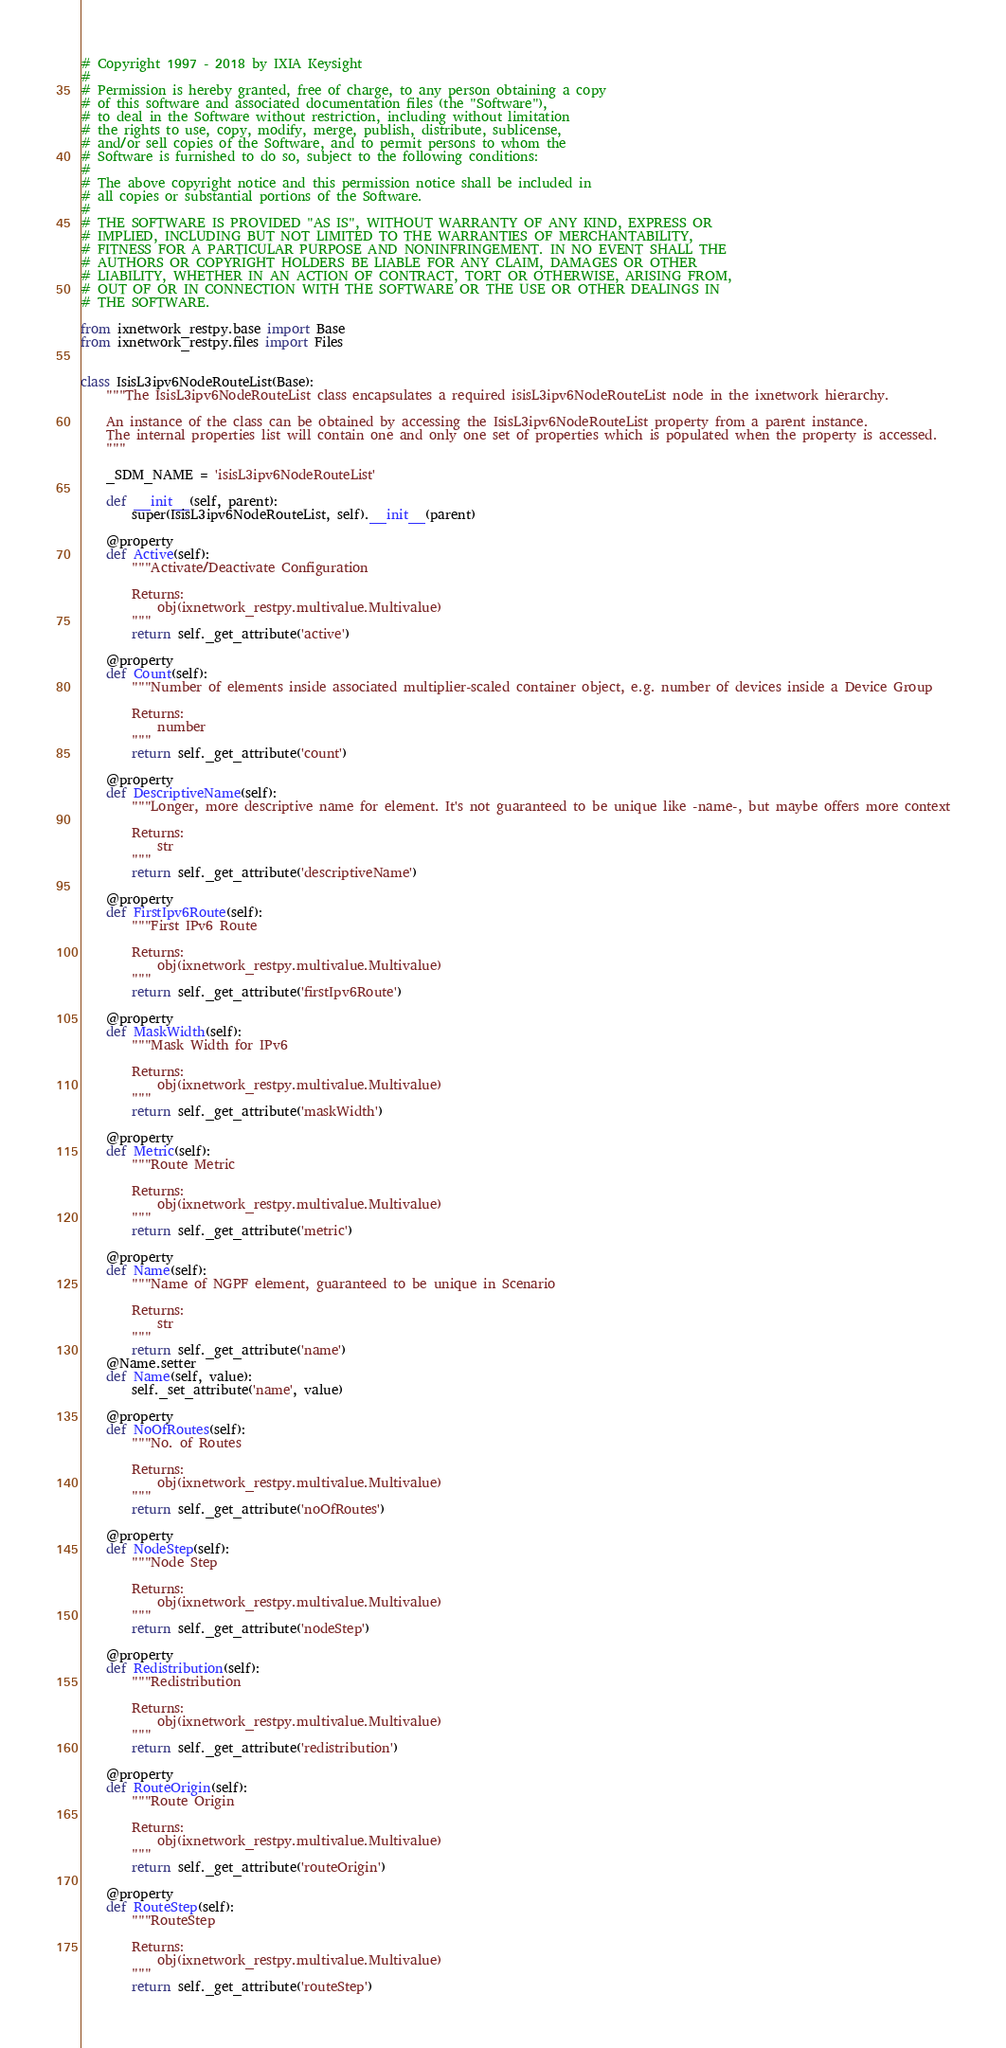Convert code to text. <code><loc_0><loc_0><loc_500><loc_500><_Python_>
# Copyright 1997 - 2018 by IXIA Keysight
#
# Permission is hereby granted, free of charge, to any person obtaining a copy
# of this software and associated documentation files (the "Software"),
# to deal in the Software without restriction, including without limitation
# the rights to use, copy, modify, merge, publish, distribute, sublicense,
# and/or sell copies of the Software, and to permit persons to whom the
# Software is furnished to do so, subject to the following conditions:
#
# The above copyright notice and this permission notice shall be included in
# all copies or substantial portions of the Software.
#
# THE SOFTWARE IS PROVIDED "AS IS", WITHOUT WARRANTY OF ANY KIND, EXPRESS OR
# IMPLIED, INCLUDING BUT NOT LIMITED TO THE WARRANTIES OF MERCHANTABILITY,
# FITNESS FOR A PARTICULAR PURPOSE AND NONINFRINGEMENT. IN NO EVENT SHALL THE
# AUTHORS OR COPYRIGHT HOLDERS BE LIABLE FOR ANY CLAIM, DAMAGES OR OTHER
# LIABILITY, WHETHER IN AN ACTION OF CONTRACT, TORT OR OTHERWISE, ARISING FROM,
# OUT OF OR IN CONNECTION WITH THE SOFTWARE OR THE USE OR OTHER DEALINGS IN
# THE SOFTWARE.
    
from ixnetwork_restpy.base import Base
from ixnetwork_restpy.files import Files


class IsisL3ipv6NodeRouteList(Base):
	"""The IsisL3ipv6NodeRouteList class encapsulates a required isisL3ipv6NodeRouteList node in the ixnetwork hierarchy.

	An instance of the class can be obtained by accessing the IsisL3ipv6NodeRouteList property from a parent instance.
	The internal properties list will contain one and only one set of properties which is populated when the property is accessed.
	"""

	_SDM_NAME = 'isisL3ipv6NodeRouteList'

	def __init__(self, parent):
		super(IsisL3ipv6NodeRouteList, self).__init__(parent)

	@property
	def Active(self):
		"""Activate/Deactivate Configuration

		Returns:
			obj(ixnetwork_restpy.multivalue.Multivalue)
		"""
		return self._get_attribute('active')

	@property
	def Count(self):
		"""Number of elements inside associated multiplier-scaled container object, e.g. number of devices inside a Device Group

		Returns:
			number
		"""
		return self._get_attribute('count')

	@property
	def DescriptiveName(self):
		"""Longer, more descriptive name for element. It's not guaranteed to be unique like -name-, but maybe offers more context

		Returns:
			str
		"""
		return self._get_attribute('descriptiveName')

	@property
	def FirstIpv6Route(self):
		"""First IPv6 Route

		Returns:
			obj(ixnetwork_restpy.multivalue.Multivalue)
		"""
		return self._get_attribute('firstIpv6Route')

	@property
	def MaskWidth(self):
		"""Mask Width for IPv6

		Returns:
			obj(ixnetwork_restpy.multivalue.Multivalue)
		"""
		return self._get_attribute('maskWidth')

	@property
	def Metric(self):
		"""Route Metric

		Returns:
			obj(ixnetwork_restpy.multivalue.Multivalue)
		"""
		return self._get_attribute('metric')

	@property
	def Name(self):
		"""Name of NGPF element, guaranteed to be unique in Scenario

		Returns:
			str
		"""
		return self._get_attribute('name')
	@Name.setter
	def Name(self, value):
		self._set_attribute('name', value)

	@property
	def NoOfRoutes(self):
		"""No. of Routes

		Returns:
			obj(ixnetwork_restpy.multivalue.Multivalue)
		"""
		return self._get_attribute('noOfRoutes')

	@property
	def NodeStep(self):
		"""Node Step

		Returns:
			obj(ixnetwork_restpy.multivalue.Multivalue)
		"""
		return self._get_attribute('nodeStep')

	@property
	def Redistribution(self):
		"""Redistribution

		Returns:
			obj(ixnetwork_restpy.multivalue.Multivalue)
		"""
		return self._get_attribute('redistribution')

	@property
	def RouteOrigin(self):
		"""Route Origin

		Returns:
			obj(ixnetwork_restpy.multivalue.Multivalue)
		"""
		return self._get_attribute('routeOrigin')

	@property
	def RouteStep(self):
		"""RouteStep

		Returns:
			obj(ixnetwork_restpy.multivalue.Multivalue)
		"""
		return self._get_attribute('routeStep')
</code> 